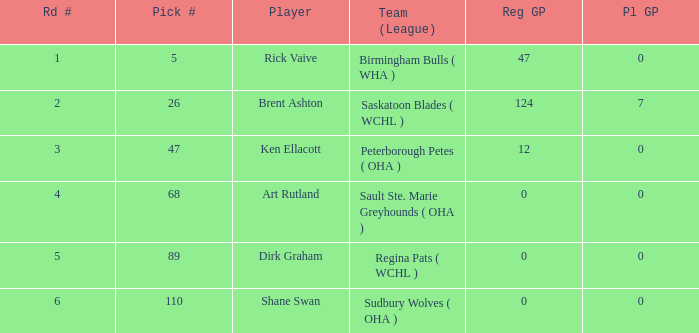What was the total number of regular gp for rick vaive in the first round? None. Could you parse the entire table? {'header': ['Rd #', 'Pick #', 'Player', 'Team (League)', 'Reg GP', 'Pl GP'], 'rows': [['1', '5', 'Rick Vaive', 'Birmingham Bulls ( WHA )', '47', '0'], ['2', '26', 'Brent Ashton', 'Saskatoon Blades ( WCHL )', '124', '7'], ['3', '47', 'Ken Ellacott', 'Peterborough Petes ( OHA )', '12', '0'], ['4', '68', 'Art Rutland', 'Sault Ste. Marie Greyhounds ( OHA )', '0', '0'], ['5', '89', 'Dirk Graham', 'Regina Pats ( WCHL )', '0', '0'], ['6', '110', 'Shane Swan', 'Sudbury Wolves ( OHA )', '0', '0']]} 